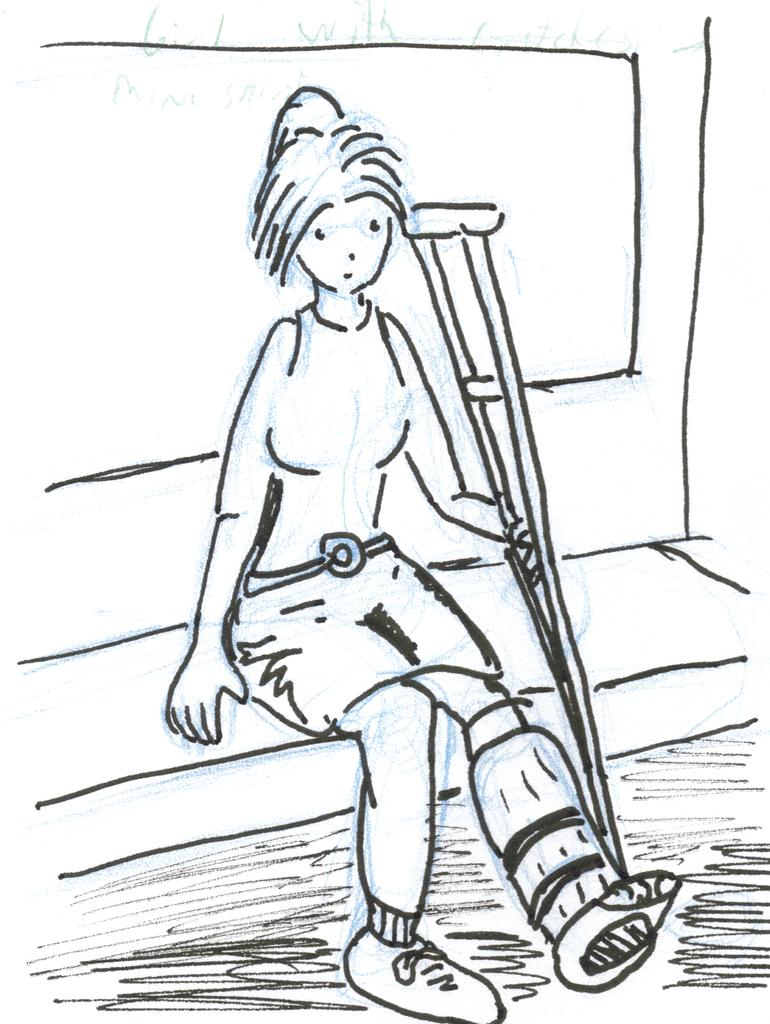What is the main subject of the drawing in the image? The drawing depicts a handicapped girl. What is the girl doing in the drawing? The girl is sitting on a bench in the drawing. What object is the girl holding in the drawing? The girl is holding a walking stick in the drawing. What type of fog can be seen surrounding the tank in the image? There is no tank or fog present in the image; it features a drawing of a handicapped girl sitting on a bench and holding a walking stick. 